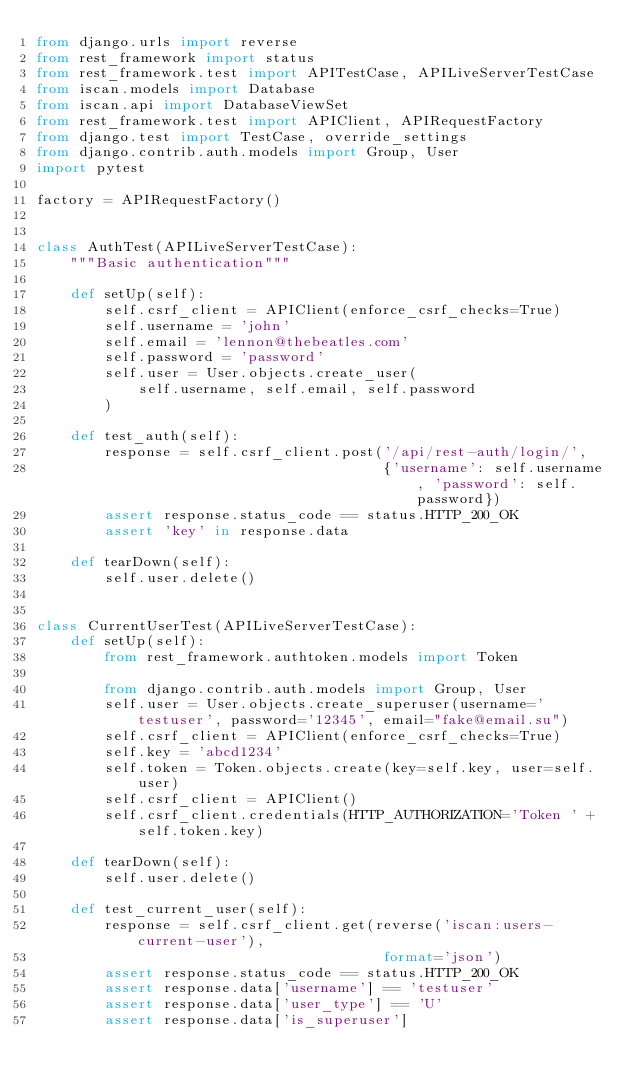<code> <loc_0><loc_0><loc_500><loc_500><_Python_>from django.urls import reverse
from rest_framework import status
from rest_framework.test import APITestCase, APILiveServerTestCase
from iscan.models import Database
from iscan.api import DatabaseViewSet
from rest_framework.test import APIClient, APIRequestFactory
from django.test import TestCase, override_settings
from django.contrib.auth.models import Group, User
import pytest

factory = APIRequestFactory()


class AuthTest(APILiveServerTestCase):
    """Basic authentication"""

    def setUp(self):
        self.csrf_client = APIClient(enforce_csrf_checks=True)
        self.username = 'john'
        self.email = 'lennon@thebeatles.com'
        self.password = 'password'
        self.user = User.objects.create_user(
            self.username, self.email, self.password
        )

    def test_auth(self):
        response = self.csrf_client.post('/api/rest-auth/login/',
                                         {'username': self.username, 'password': self.password})
        assert response.status_code == status.HTTP_200_OK
        assert 'key' in response.data

    def tearDown(self):
        self.user.delete()


class CurrentUserTest(APILiveServerTestCase):
    def setUp(self):
        from rest_framework.authtoken.models import Token

        from django.contrib.auth.models import Group, User
        self.user = User.objects.create_superuser(username='testuser', password='12345', email="fake@email.su")
        self.csrf_client = APIClient(enforce_csrf_checks=True)
        self.key = 'abcd1234'
        self.token = Token.objects.create(key=self.key, user=self.user)
        self.csrf_client = APIClient()
        self.csrf_client.credentials(HTTP_AUTHORIZATION='Token ' + self.token.key)

    def tearDown(self):
        self.user.delete()

    def test_current_user(self):
        response = self.csrf_client.get(reverse('iscan:users-current-user'),
                                         format='json')
        assert response.status_code == status.HTTP_200_OK
        assert response.data['username'] == 'testuser'
        assert response.data['user_type'] == 'U'
        assert response.data['is_superuser']


</code> 